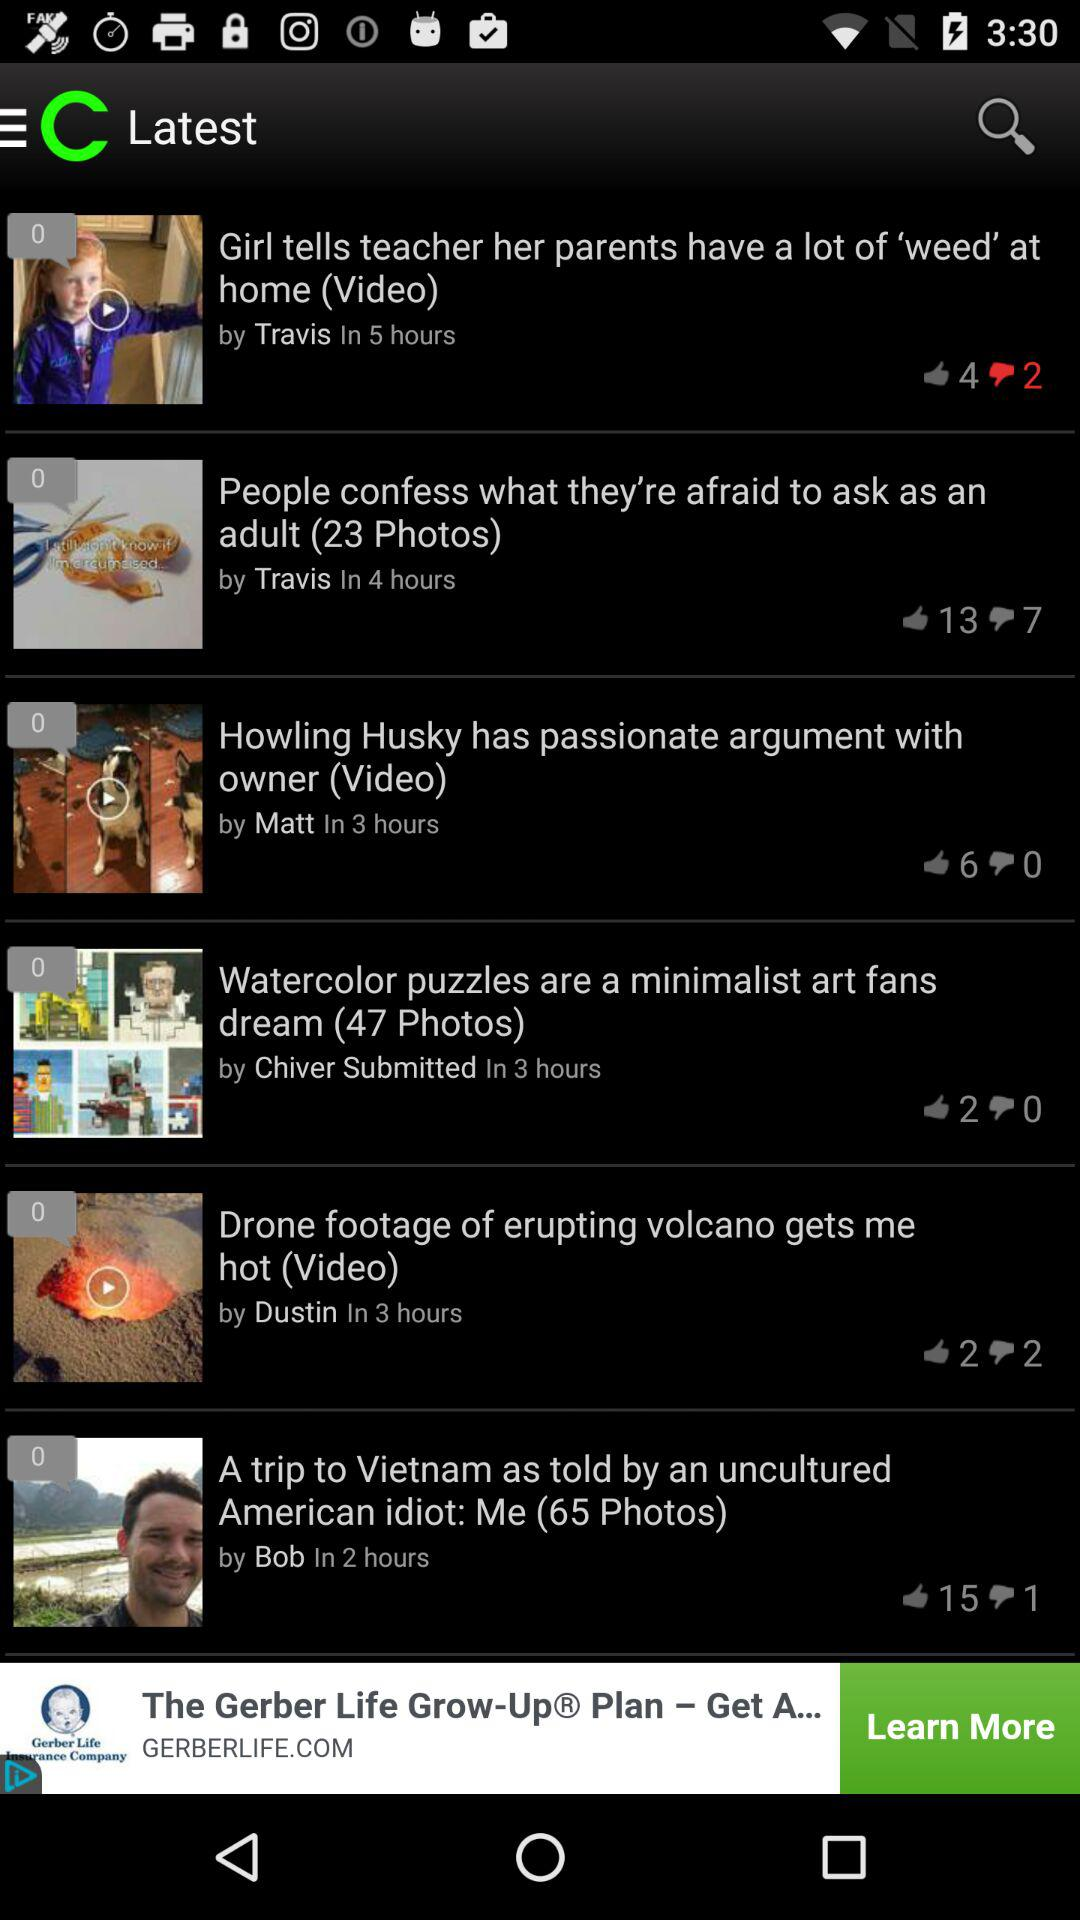How many more thumbs up does the video about the trip to Vietnam have than the video about the husky arguing with his owner?
Answer the question using a single word or phrase. 9 